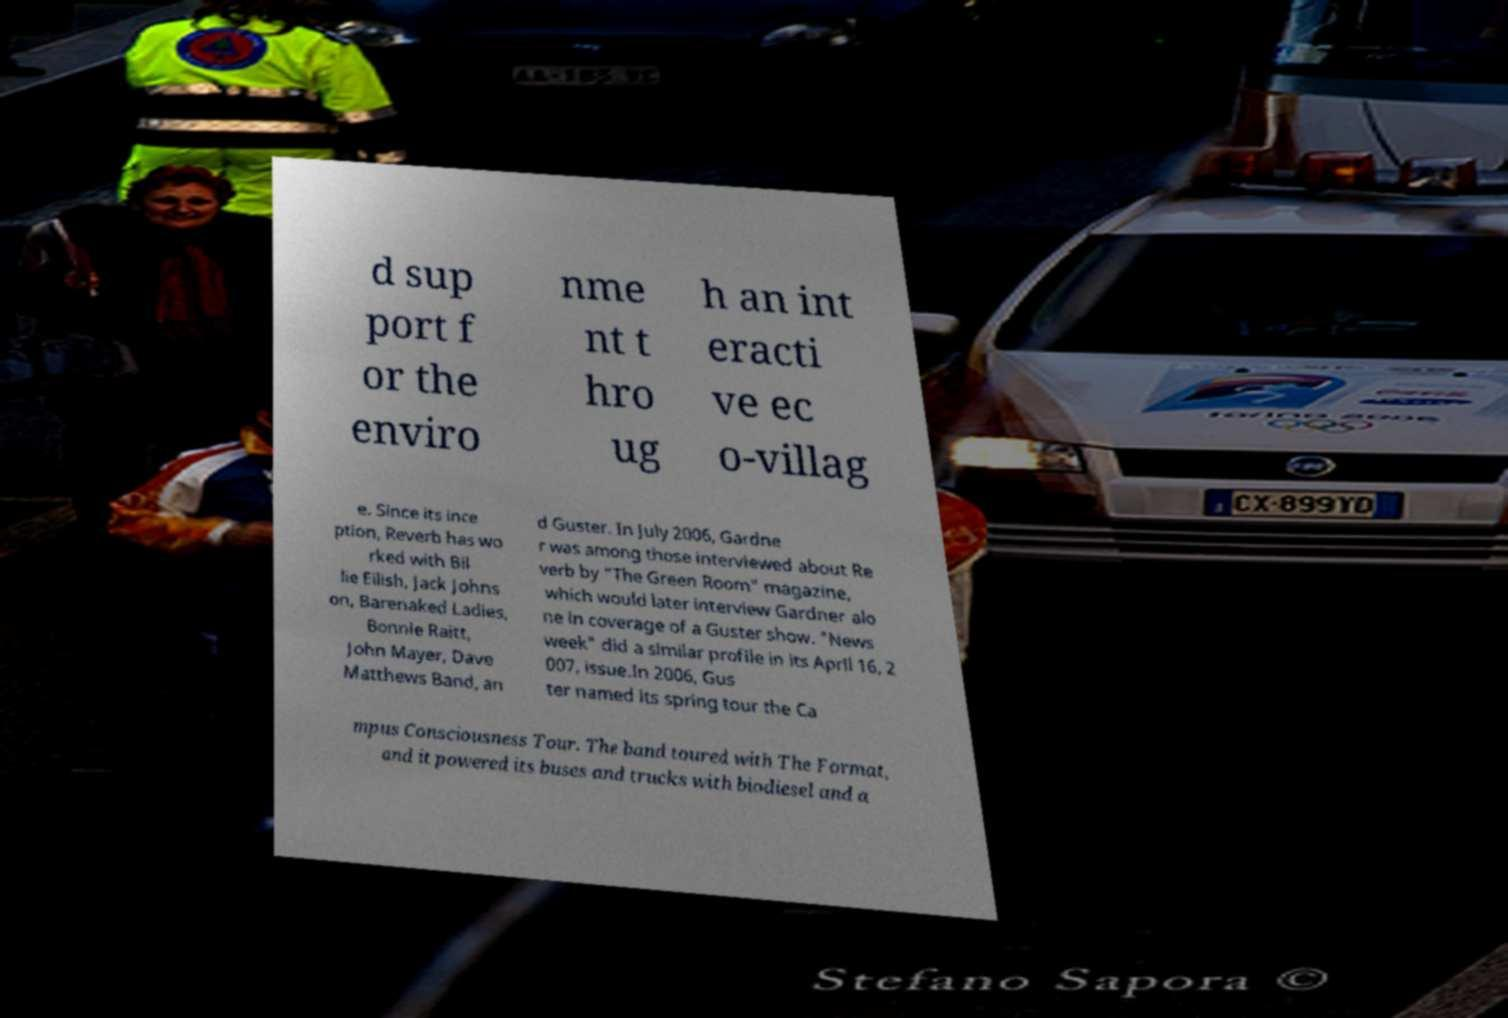What messages or text are displayed in this image? I need them in a readable, typed format. d sup port f or the enviro nme nt t hro ug h an int eracti ve ec o-villag e. Since its ince ption, Reverb has wo rked with Bil lie Eilish, Jack Johns on, Barenaked Ladies, Bonnie Raitt, John Mayer, Dave Matthews Band, an d Guster. In July 2006, Gardne r was among those interviewed about Re verb by "The Green Room" magazine, which would later interview Gardner alo ne in coverage of a Guster show. "News week" did a similar profile in its April 16, 2 007, issue.In 2006, Gus ter named its spring tour the Ca mpus Consciousness Tour. The band toured with The Format, and it powered its buses and trucks with biodiesel and a 